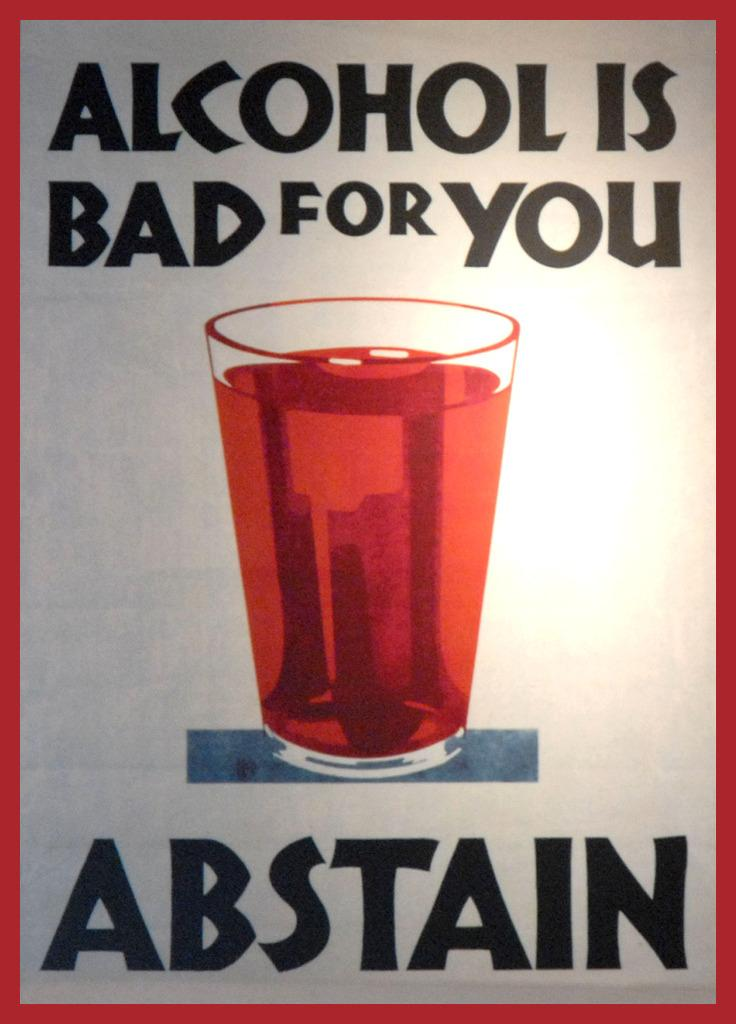<image>
Give a short and clear explanation of the subsequent image. Advertisement poster saying Alcohol is Bad for You Abstain with a glass of beer in the middle. 